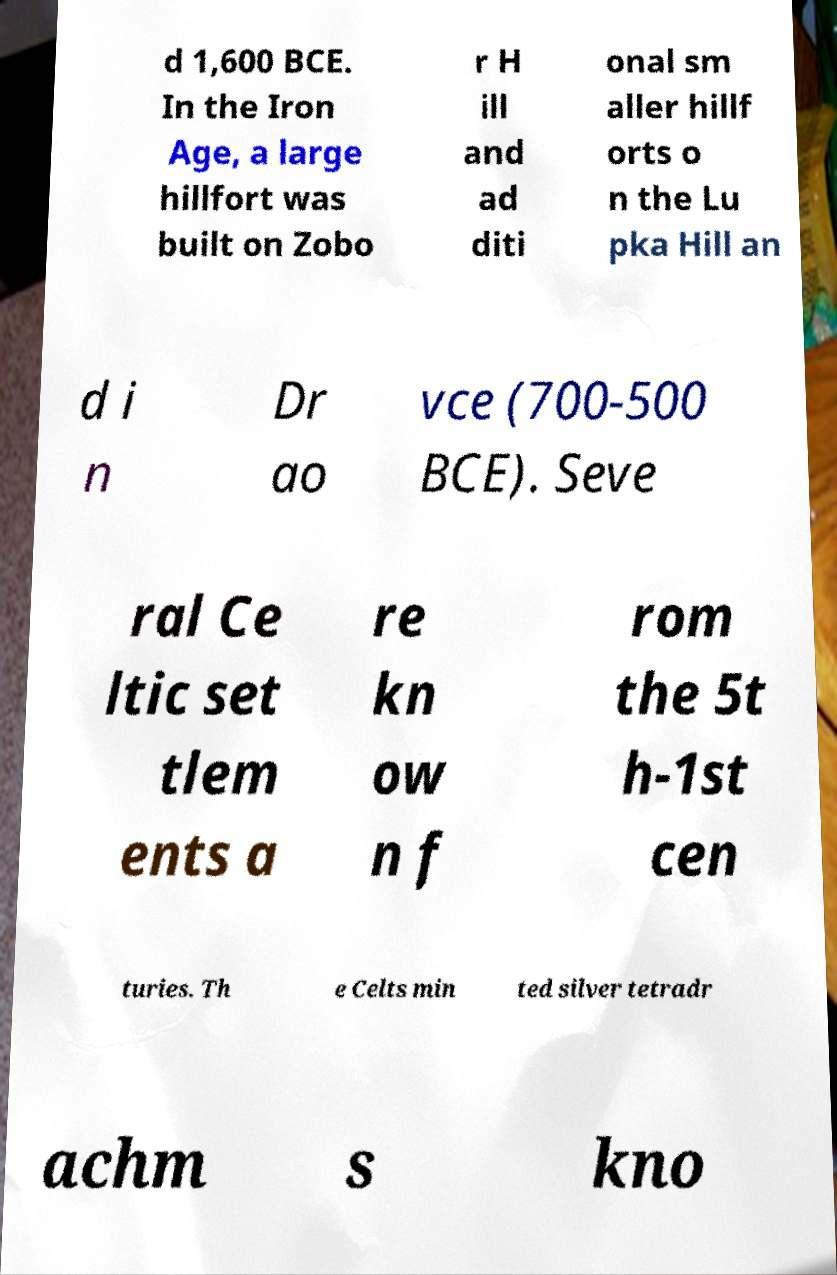For documentation purposes, I need the text within this image transcribed. Could you provide that? d 1,600 BCE. In the Iron Age, a large hillfort was built on Zobo r H ill and ad diti onal sm aller hillf orts o n the Lu pka Hill an d i n Dr ao vce (700-500 BCE). Seve ral Ce ltic set tlem ents a re kn ow n f rom the 5t h-1st cen turies. Th e Celts min ted silver tetradr achm s kno 